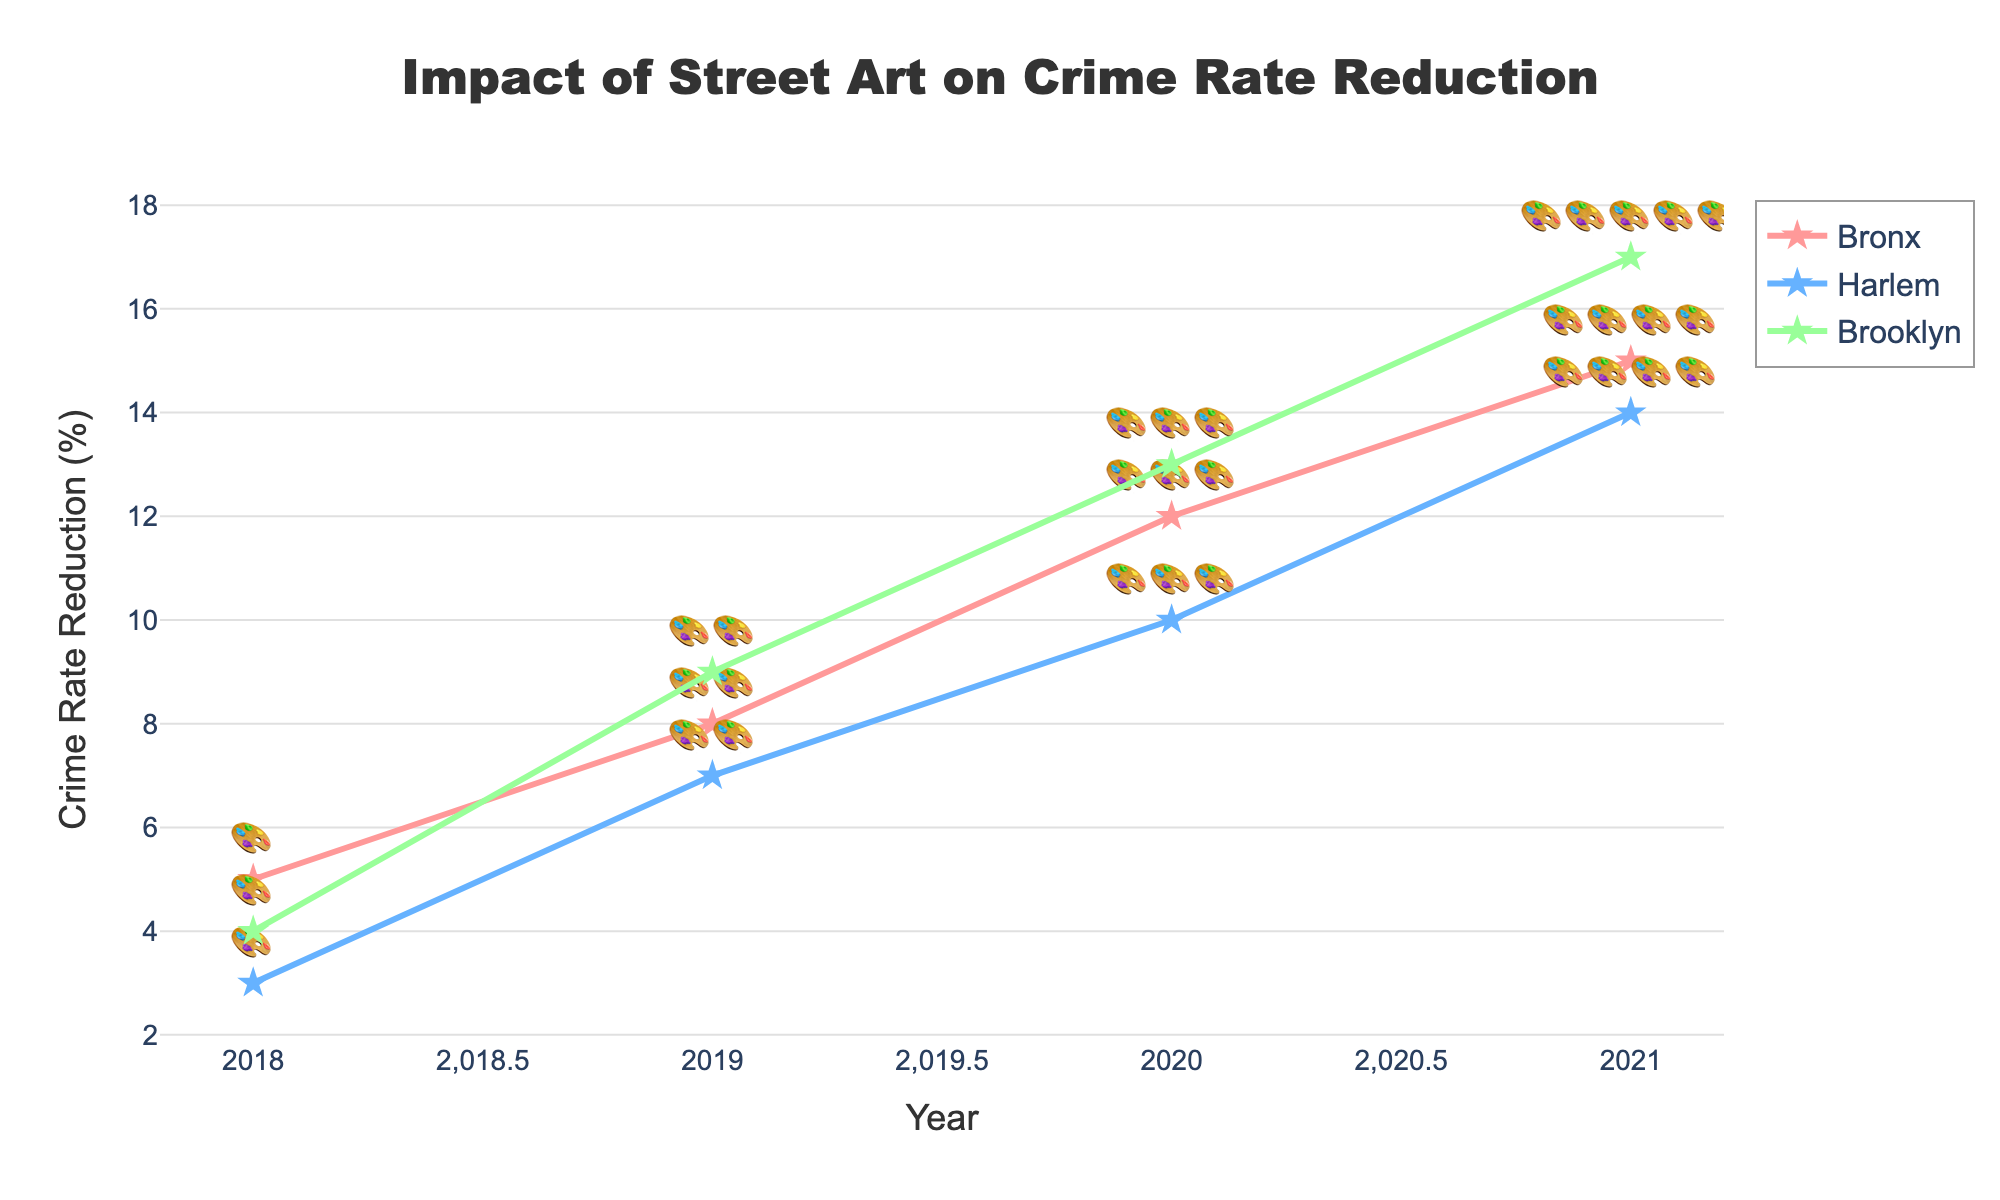what is the title of the figure? The title of the figure is displayed prominently at the top center of the plot.
Answer: Impact of Street Art on Crime Rate Reduction Which year saw the highest reduction in crime rates for Brooklyn? The plot shows the crime rate reduction values on the y-axis and the year on the x-axis. Checking the Brooklyn line, the highest reduction is in 2021.
Answer: 2021 How many Street Art Projects were carried out in Harlem in 2019? The number of street art projects is indicated by the number of painting emojis next to the data point. For Harlem in 2019, there are two emojis.
Answer: 2 What is the difference in the crime rate reduction between Bronx and Harlem in 2021? In 2021, Bronx had a 15% reduction and Harlem had a 14% reduction. The difference is 15 - 14.
Answer: 1% Which district had the highest increase in crime rate reduction from 2020 to 2021? To find the district with the highest increase, compare the crime rate reduction percentage from 2020 to 2021 for each district. Bronx increased by 3%, Harlem increased by 4%, and Brooklyn increased by 4%. Hence, Harlem and Brooklyn both had the highest increase.
Answer: Harlem and Brooklyn What is the trend of crime rate reduction in the Bronx from 2018 to 2021? Examine the plot for how the crime rate reduction line for the Bronx changes over the years. It shows a steady increase.
Answer: Steadily increasing How many total Street Art Projects were carried out in Brooklyn by 2021? By summing the number of emojis (projects) shown for each year in Brooklyn (1 in 2018, 2 in 2019, 3 in 2020, 4 in 2021), the total is 1 + 2 + 3 + 4.
Answer: 10 Is there a consistent correlation between the increase in Street Art Projects and crime rate reduction in Harlem? Looking at the data points in Harlem from 2018 to 2021, as the number of street art projects increase (1, 2, 3, 4), the crime rate reduction also steadily increases.
Answer: Yes In which year did all districts start showing significant improvements in crime rate reduction? Checking the plot for significant increases, noticeable uniform improvements across all districts begin around 2020 and onwards.
Answer: 2020 How do the crime rate reductions in 2019 compare across all districts? By examining the values for 2019: Bronx had 8%, Harlem had 7%, and Brooklyn had 9%. Brooklyn had the highest, followed by Bronx, and then Harlem.
Answer: Brooklyn > Bronx > Harlem 